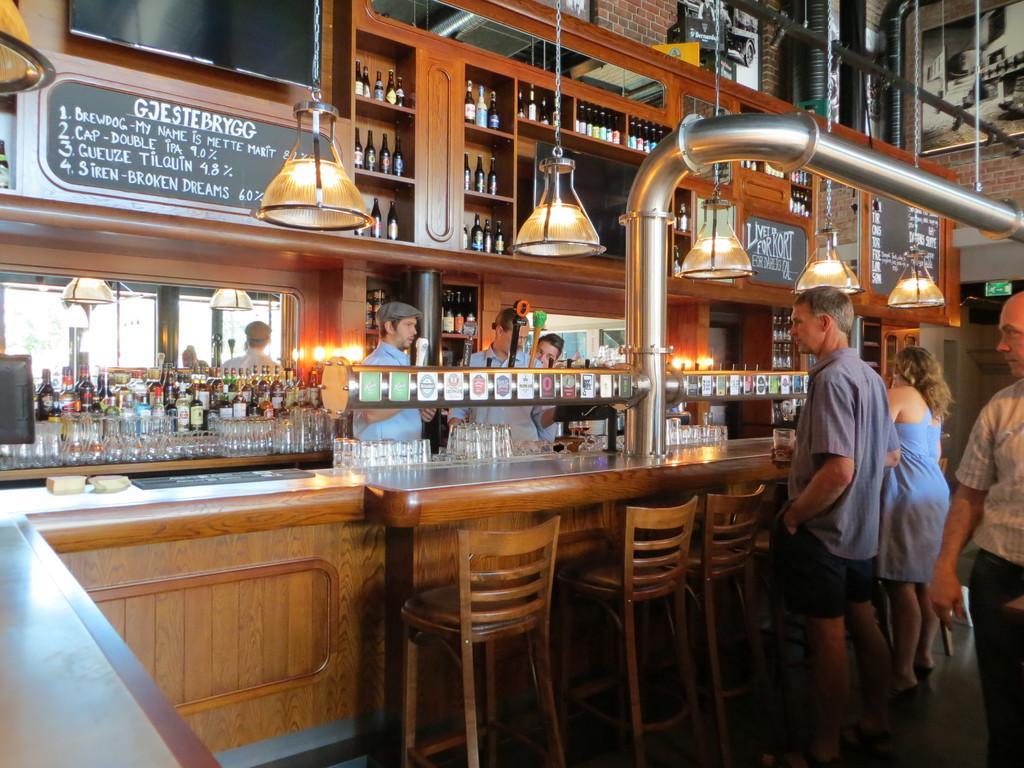How would you summarize this image in a sentence or two? This is an inside view picture. Here we can see bottles in cupboards. these are lights. these are boards. We can see persons standing in front of a table and there are chairs. 